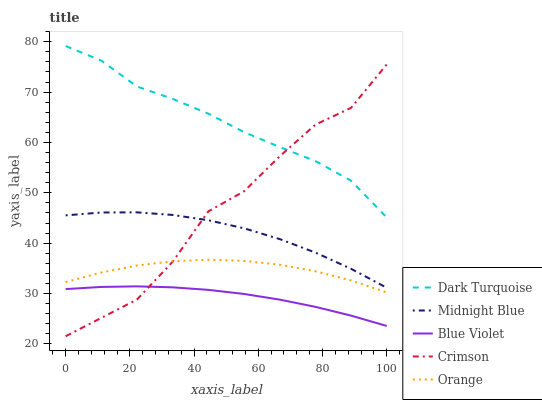Does Blue Violet have the minimum area under the curve?
Answer yes or no. Yes. Does Dark Turquoise have the maximum area under the curve?
Answer yes or no. Yes. Does Orange have the minimum area under the curve?
Answer yes or no. No. Does Orange have the maximum area under the curve?
Answer yes or no. No. Is Blue Violet the smoothest?
Answer yes or no. Yes. Is Crimson the roughest?
Answer yes or no. Yes. Is Dark Turquoise the smoothest?
Answer yes or no. No. Is Dark Turquoise the roughest?
Answer yes or no. No. Does Orange have the lowest value?
Answer yes or no. No. Does Dark Turquoise have the highest value?
Answer yes or no. Yes. Does Orange have the highest value?
Answer yes or no. No. Is Blue Violet less than Midnight Blue?
Answer yes or no. Yes. Is Dark Turquoise greater than Orange?
Answer yes or no. Yes. Does Crimson intersect Orange?
Answer yes or no. Yes. Is Crimson less than Orange?
Answer yes or no. No. Is Crimson greater than Orange?
Answer yes or no. No. Does Blue Violet intersect Midnight Blue?
Answer yes or no. No. 